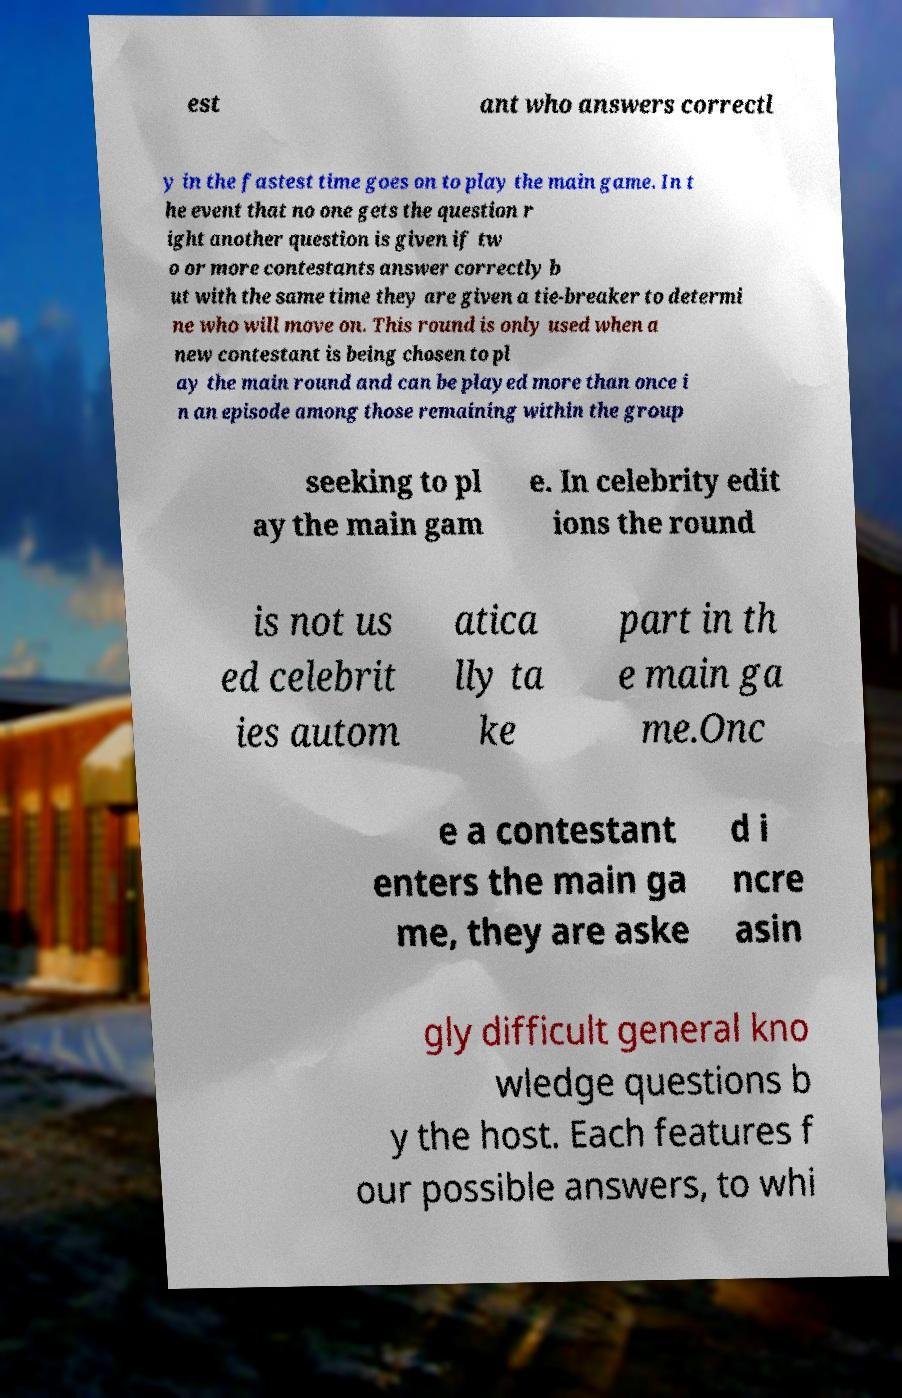Could you extract and type out the text from this image? est ant who answers correctl y in the fastest time goes on to play the main game. In t he event that no one gets the question r ight another question is given if tw o or more contestants answer correctly b ut with the same time they are given a tie-breaker to determi ne who will move on. This round is only used when a new contestant is being chosen to pl ay the main round and can be played more than once i n an episode among those remaining within the group seeking to pl ay the main gam e. In celebrity edit ions the round is not us ed celebrit ies autom atica lly ta ke part in th e main ga me.Onc e a contestant enters the main ga me, they are aske d i ncre asin gly difficult general kno wledge questions b y the host. Each features f our possible answers, to whi 